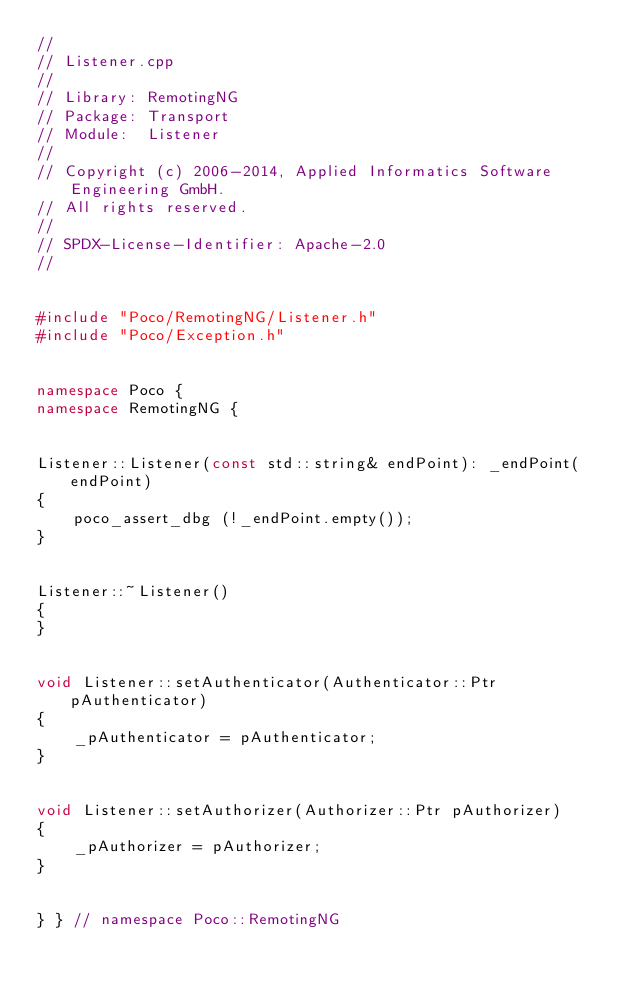<code> <loc_0><loc_0><loc_500><loc_500><_C++_>//
// Listener.cpp
//
// Library: RemotingNG
// Package: Transport
// Module:  Listener
//
// Copyright (c) 2006-2014, Applied Informatics Software Engineering GmbH.
// All rights reserved.
//
// SPDX-License-Identifier: Apache-2.0
//


#include "Poco/RemotingNG/Listener.h"
#include "Poco/Exception.h"


namespace Poco {
namespace RemotingNG {


Listener::Listener(const std::string& endPoint): _endPoint(endPoint)
{
	poco_assert_dbg (!_endPoint.empty());
}


Listener::~Listener()
{
}


void Listener::setAuthenticator(Authenticator::Ptr pAuthenticator)
{
	_pAuthenticator = pAuthenticator;
}


void Listener::setAuthorizer(Authorizer::Ptr pAuthorizer)
{
	_pAuthorizer = pAuthorizer;
}


} } // namespace Poco::RemotingNG
</code> 